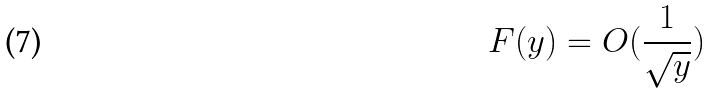<formula> <loc_0><loc_0><loc_500><loc_500>F ( y ) = O ( \frac { 1 } { \sqrt { y } } )</formula> 